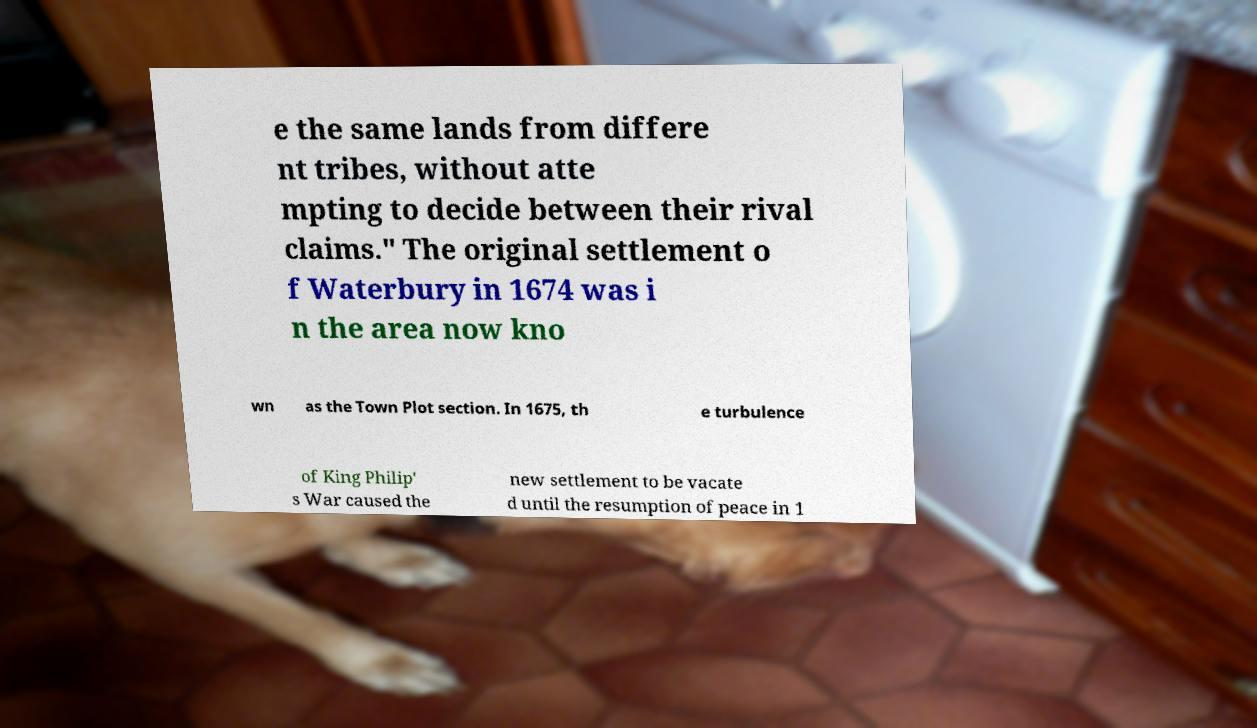What messages or text are displayed in this image? I need them in a readable, typed format. e the same lands from differe nt tribes, without atte mpting to decide between their rival claims." The original settlement o f Waterbury in 1674 was i n the area now kno wn as the Town Plot section. In 1675, th e turbulence of King Philip' s War caused the new settlement to be vacate d until the resumption of peace in 1 